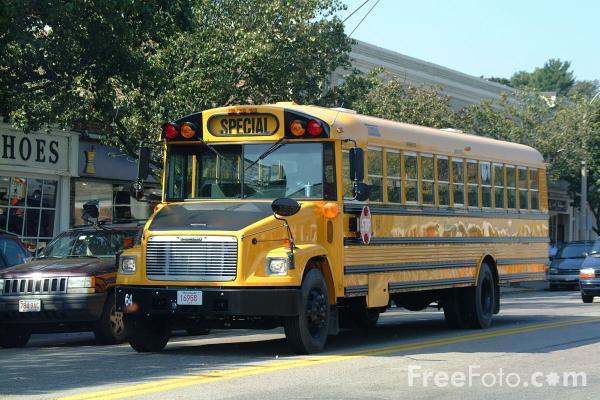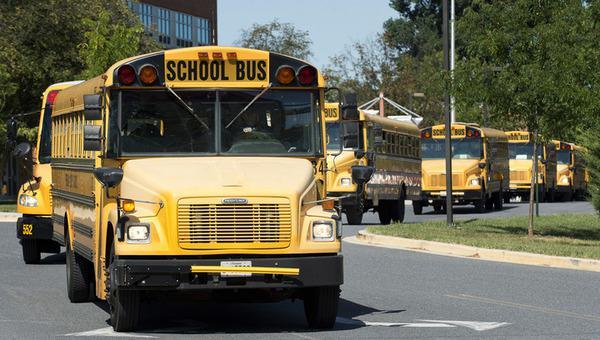The first image is the image on the left, the second image is the image on the right. Analyze the images presented: Is the assertion "The lefthand image shows a side-view of a parked yellow bus facing rightward, with its entry door opened." valid? Answer yes or no. No. The first image is the image on the left, the second image is the image on the right. Assess this claim about the two images: "One of the buses is built with a house door.". Correct or not? Answer yes or no. No. 